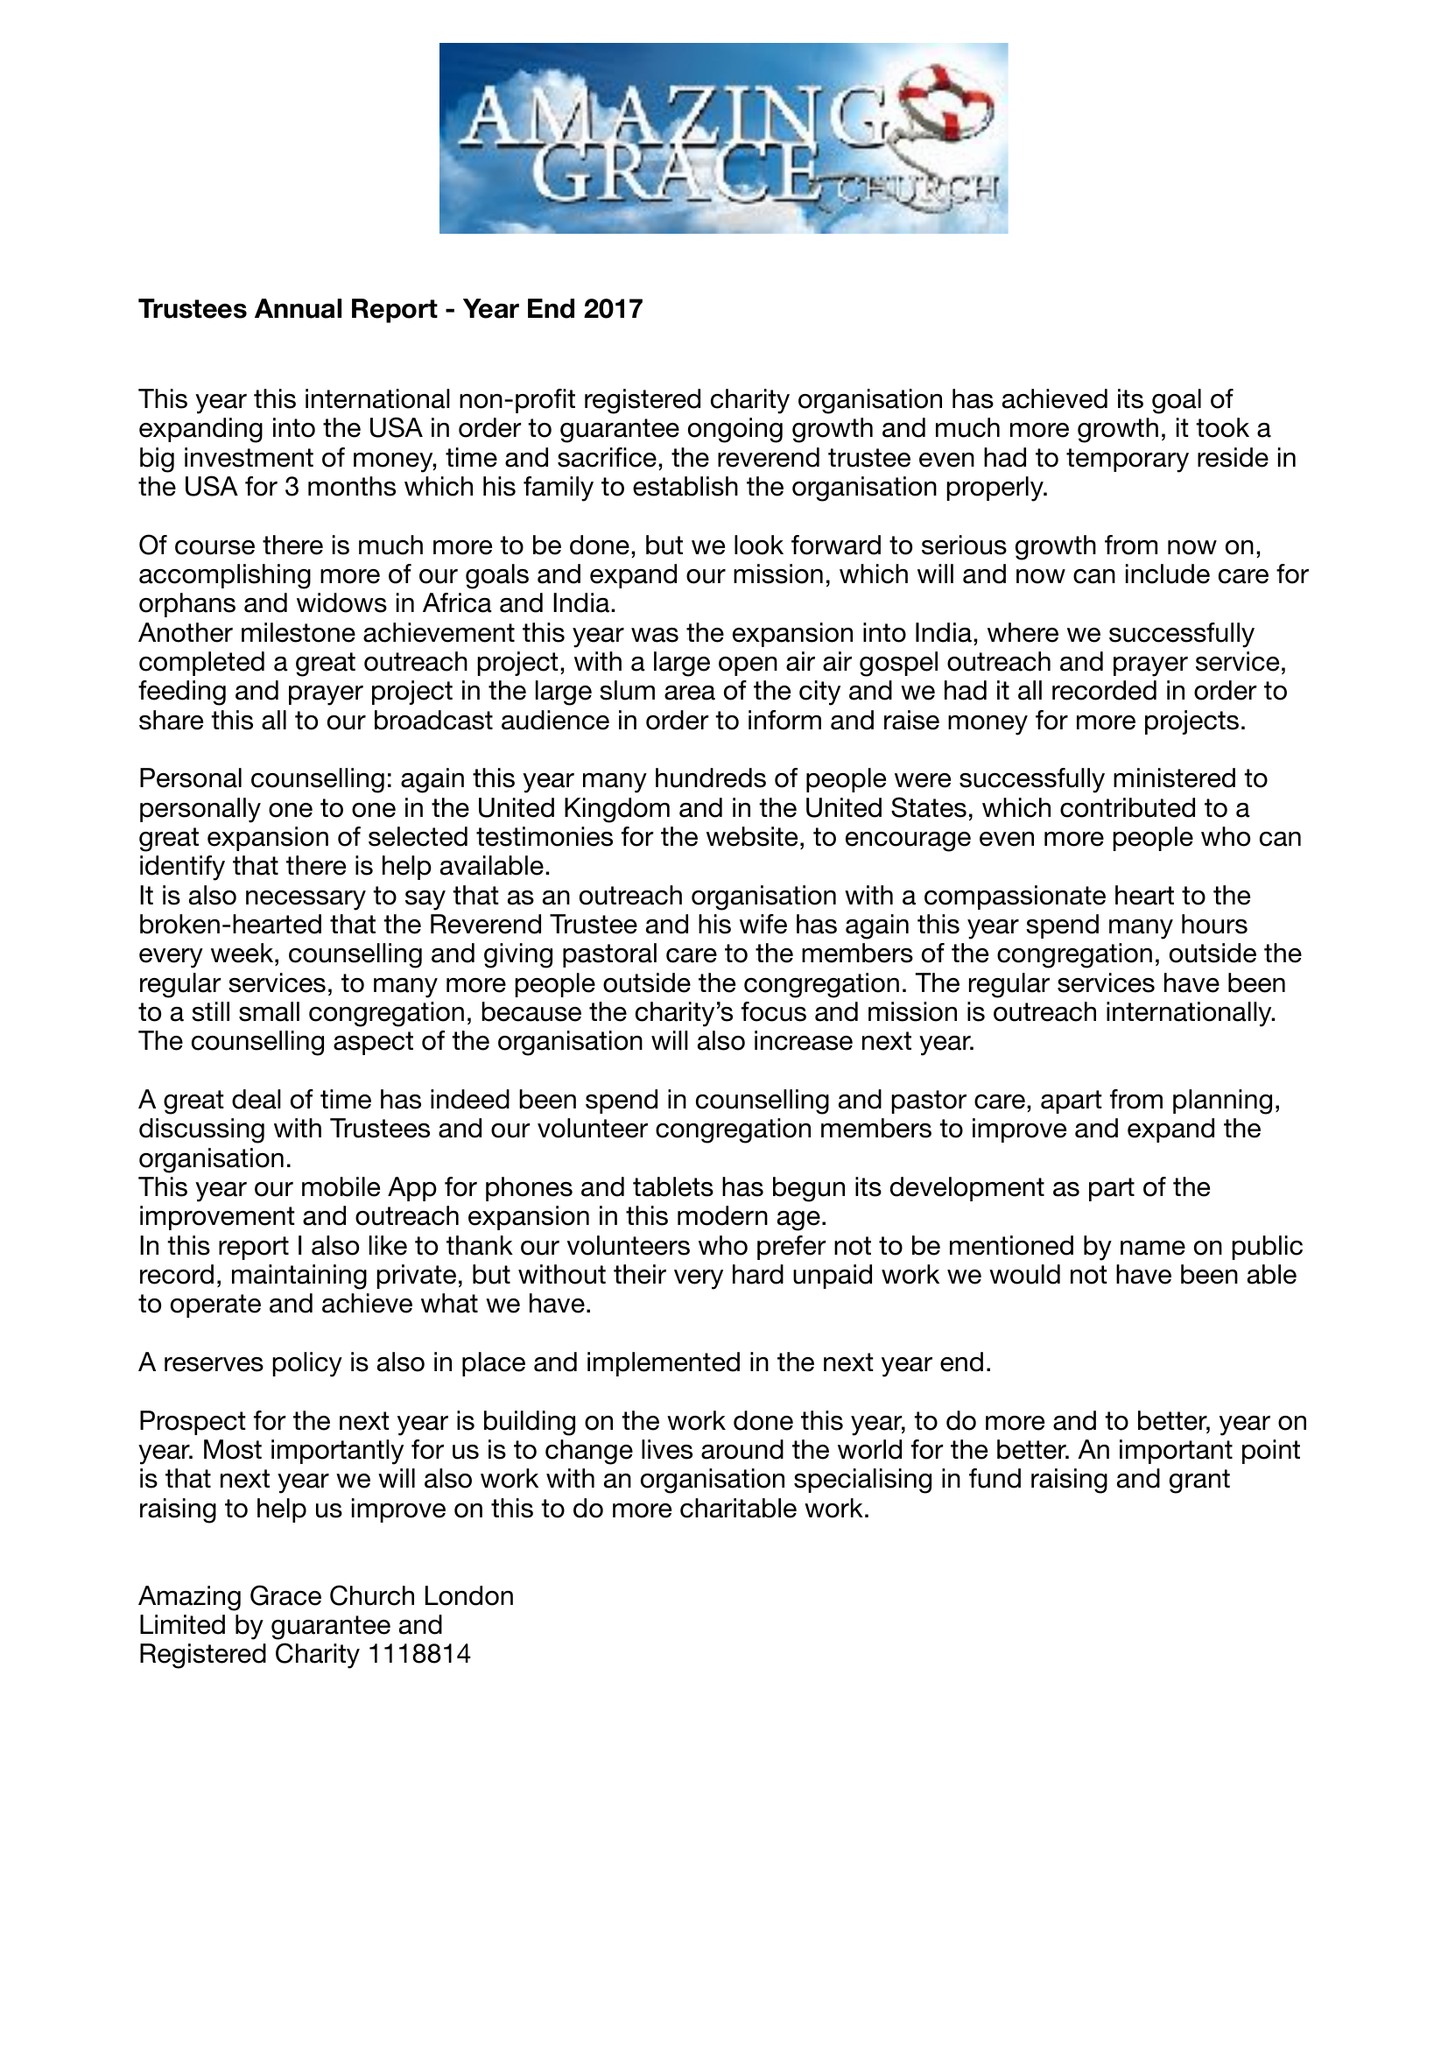What is the value for the charity_number?
Answer the question using a single word or phrase. 1118814 